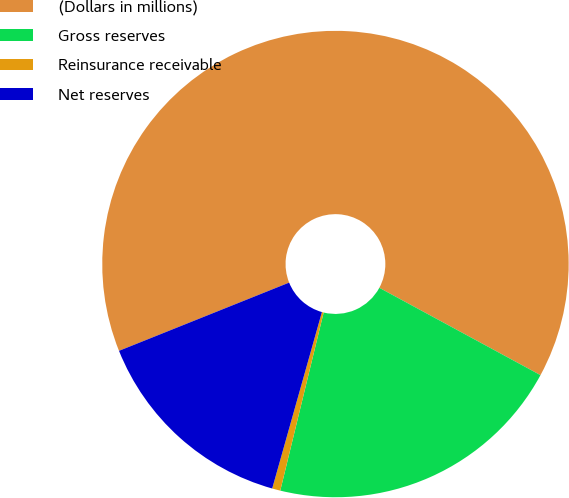Convert chart. <chart><loc_0><loc_0><loc_500><loc_500><pie_chart><fcel>(Dollars in millions)<fcel>Gross reserves<fcel>Reinsurance receivable<fcel>Net reserves<nl><fcel>63.98%<fcel>20.9%<fcel>0.57%<fcel>14.56%<nl></chart> 